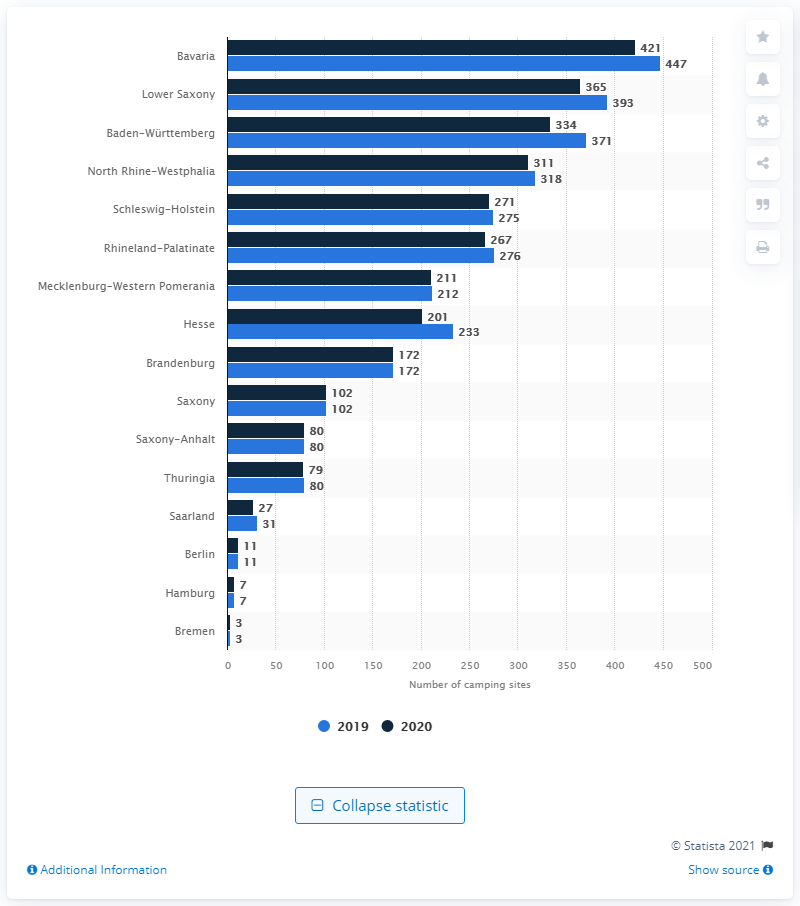Which state had the highest number of camping sites in Germany in 2020?
 Bavaria 